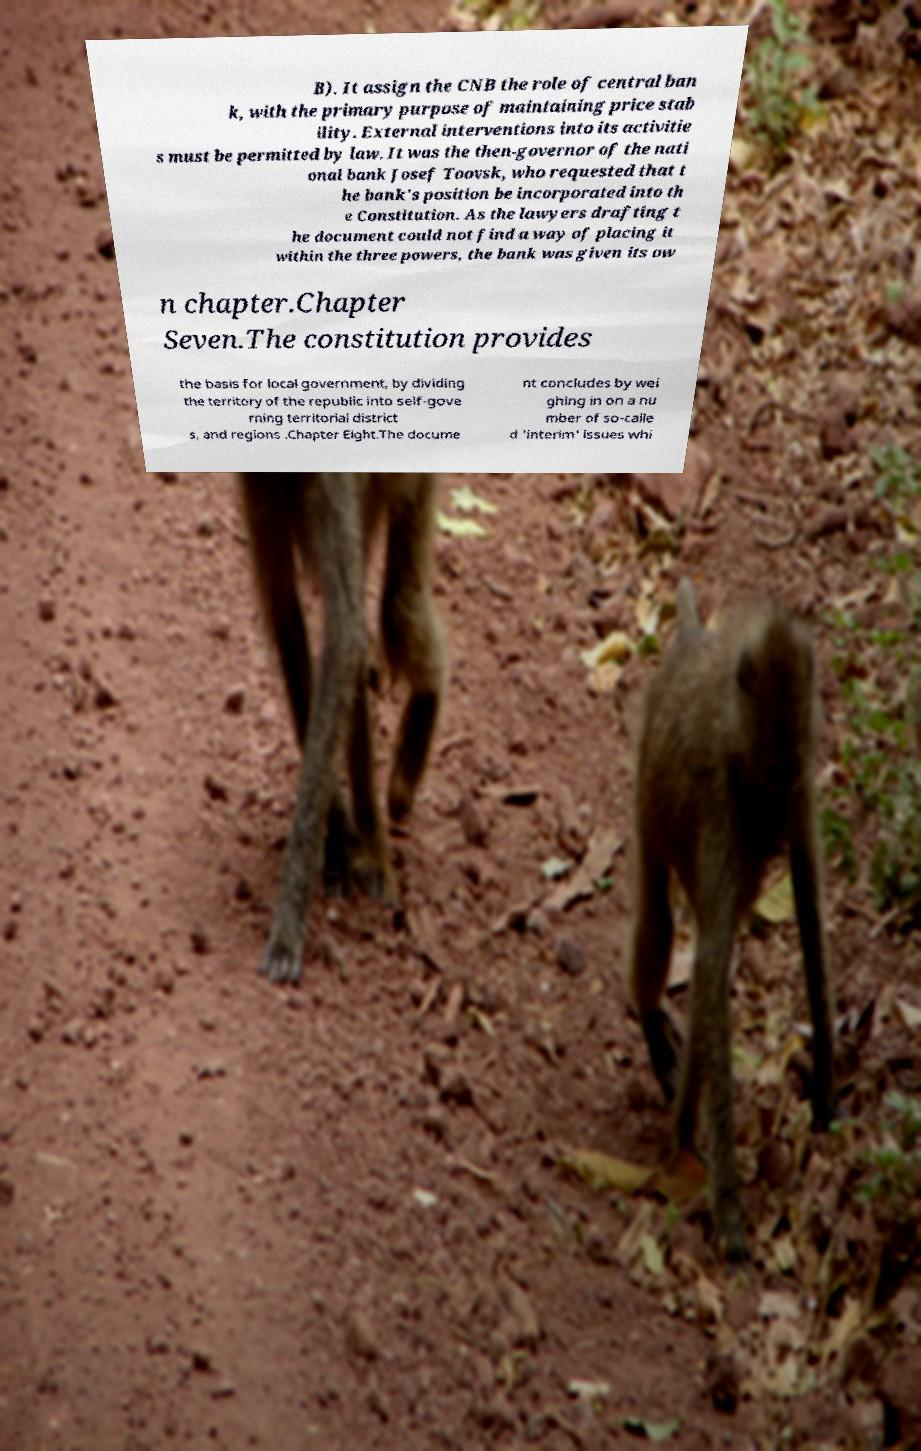Can you accurately transcribe the text from the provided image for me? B). It assign the CNB the role of central ban k, with the primary purpose of maintaining price stab ility. External interventions into its activitie s must be permitted by law. It was the then-governor of the nati onal bank Josef Toovsk, who requested that t he bank's position be incorporated into th e Constitution. As the lawyers drafting t he document could not find a way of placing it within the three powers, the bank was given its ow n chapter.Chapter Seven.The constitution provides the basis for local government, by dividing the territory of the republic into self-gove rning territorial district s, and regions .Chapter Eight.The docume nt concludes by wei ghing in on a nu mber of so-calle d 'interim' issues whi 